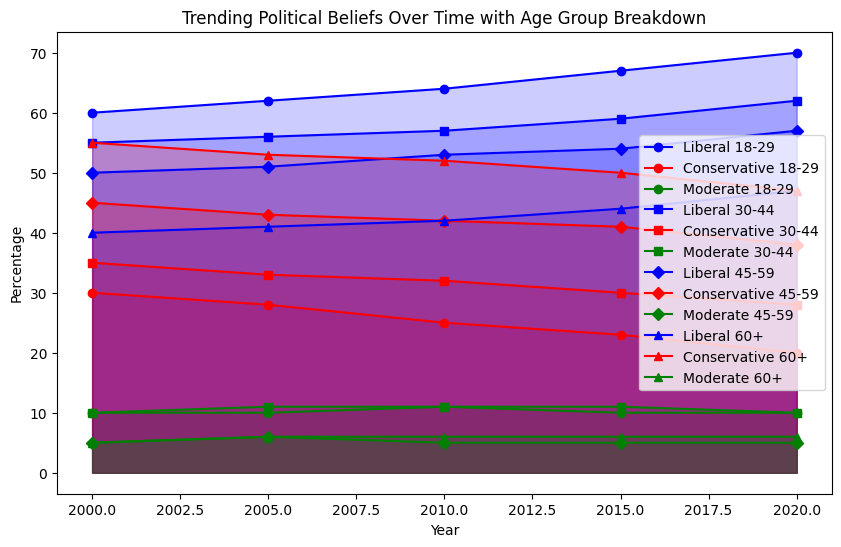What's the overall trend of the Liberal political belief for the 18-29 age group from 2000 to 2020? The Liberal belief in the 18-29 age group consistently increased over the years. It went from 60% in 2000 to 70% in 2020.
Answer: Increasing For which age group did the percentage of Conservative beliefs remain the highest throughout the period from 2000 to 2020? The 60+ age group consistently had the highest percentage of Conservative beliefs throughout the period, starting at 55% in 2000 and ending at 47% in 2020.
Answer: 60+ Which age group had the smallest change in Moderate beliefs from 2000 to 2020? The 45-59 age group had the smallest change in Moderate beliefs, which remained constant at 5% throughout the period.
Answer: 45-59 In 2015, which age group had the highest percentage of Liberal beliefs, and what was that percentage? The 18-29 age group had the highest percentage of Liberal beliefs in 2015, which was 67%.
Answer: 18-29, 67% Comparing 2000 and 2020, which age group saw the largest increase in Liberal beliefs and by how much? The 18-29 age group saw the largest increase in Liberal beliefs, increasing from 60% in 2000 to 70% in 2020. The change is 70% - 60% = 10%.
Answer: 18-29, 10% Between 2000 and 2020, which age group showed the most significant decrease in Conservative beliefs? The 60+ age group showed the most significant decrease in Conservative beliefs, from 55% in 2000 to 47% in 2020, which is a decrease of 8%.
Answer: 60+, 8% Which age group had equal percentages of Liberal and Conservative beliefs in 2020 and what was the percentage? In 2020, the 60+ age group had equal percentages of Liberal and Conservative beliefs, both at 47%.
Answer: 60+, 47% By looking at the visual attributes, which age group and political belief showed the most noticeable upward slope from 2000 to 2020? The 18-29 age group and the Liberal belief showed the most noticeable upward slope, visually rising consistently from 60% to 70%.
Answer: 18-29, Liberal 